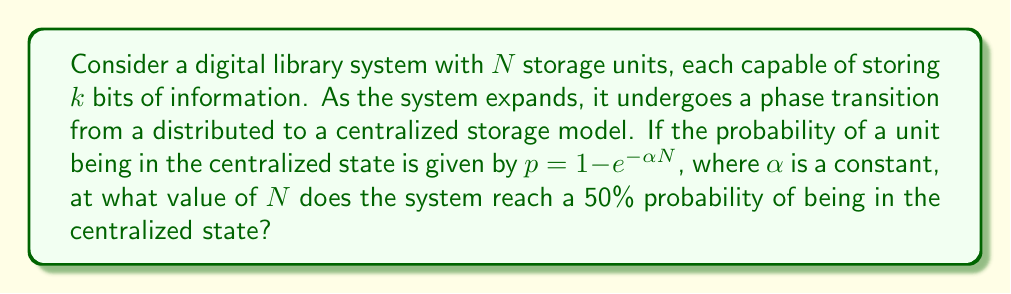Show me your answer to this math problem. To solve this problem, we'll follow these steps:

1) We're looking for the value of $N$ where $p = 0.5$, representing a 50% probability of being in the centralized state.

2) We can set up the equation:

   $0.5 = 1 - e^{-\alpha N}$

3) Rearranging the equation:

   $e^{-\alpha N} = 0.5$

4) Taking the natural logarithm of both sides:

   $-\alpha N = \ln(0.5)$

5) Solving for $N$:

   $N = -\frac{\ln(0.5)}{\alpha}$

6) We know that $\ln(0.5) = -\ln(2)$, so we can simplify:

   $N = \frac{\ln(2)}{\alpha}$

This gives us the number of storage units at which the system has a 50% probability of being in the centralized state.
Answer: $N = \frac{\ln(2)}{\alpha}$ 